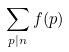Convert formula to latex. <formula><loc_0><loc_0><loc_500><loc_500>\sum _ { p | n } f ( p )</formula> 